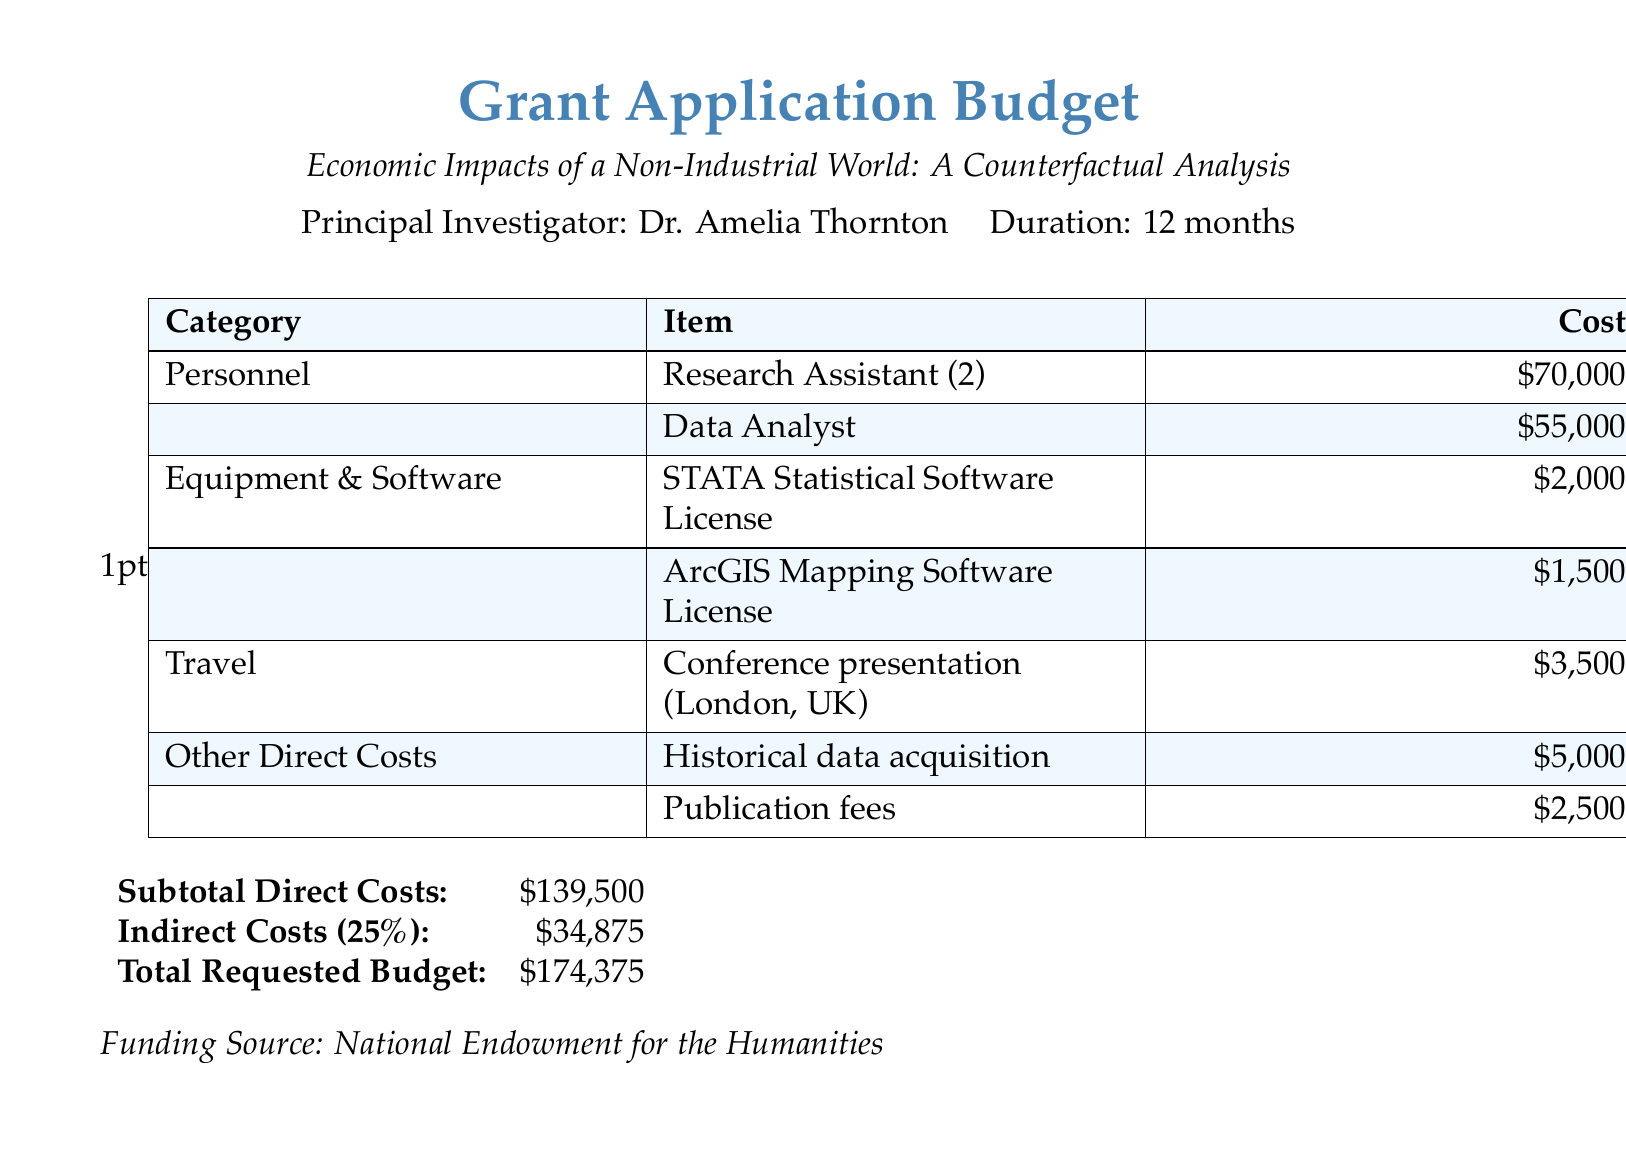What is the total requested budget? The total requested budget is clearly stated at the end of the document.
Answer: $174,375 Who is the principal investigator? The document specifies the principal investigator's name at the beginning.
Answer: Dr. Amelia Thornton How many research assistants are included in the budget? The budget lists the number of research assistants under the Personnel category.
Answer: 2 What is the cost of the ArcGIS Mapping Software License? The document provides specific costs for equipment and software in the table.
Answer: $1,500 What is the subtotal direct costs? The subtotal direct costs is calculated from the listed expenses and is provided in the document.
Answer: $139,500 What percentage of the costs are indirect costs? The document indicates the percentage for indirect costs in the summary section.
Answer: 25% What is the cost for historical data acquisition? This cost is detailed in the Other Direct Costs section of the budget.
Answer: $5,000 How much is allocated for conference travel? The travel cost for conference presentation is explicitly mentioned in the table.
Answer: $3,500 What is the funding source for this project? The funding source is stated at the bottom of the document.
Answer: National Endowment for the Humanities 